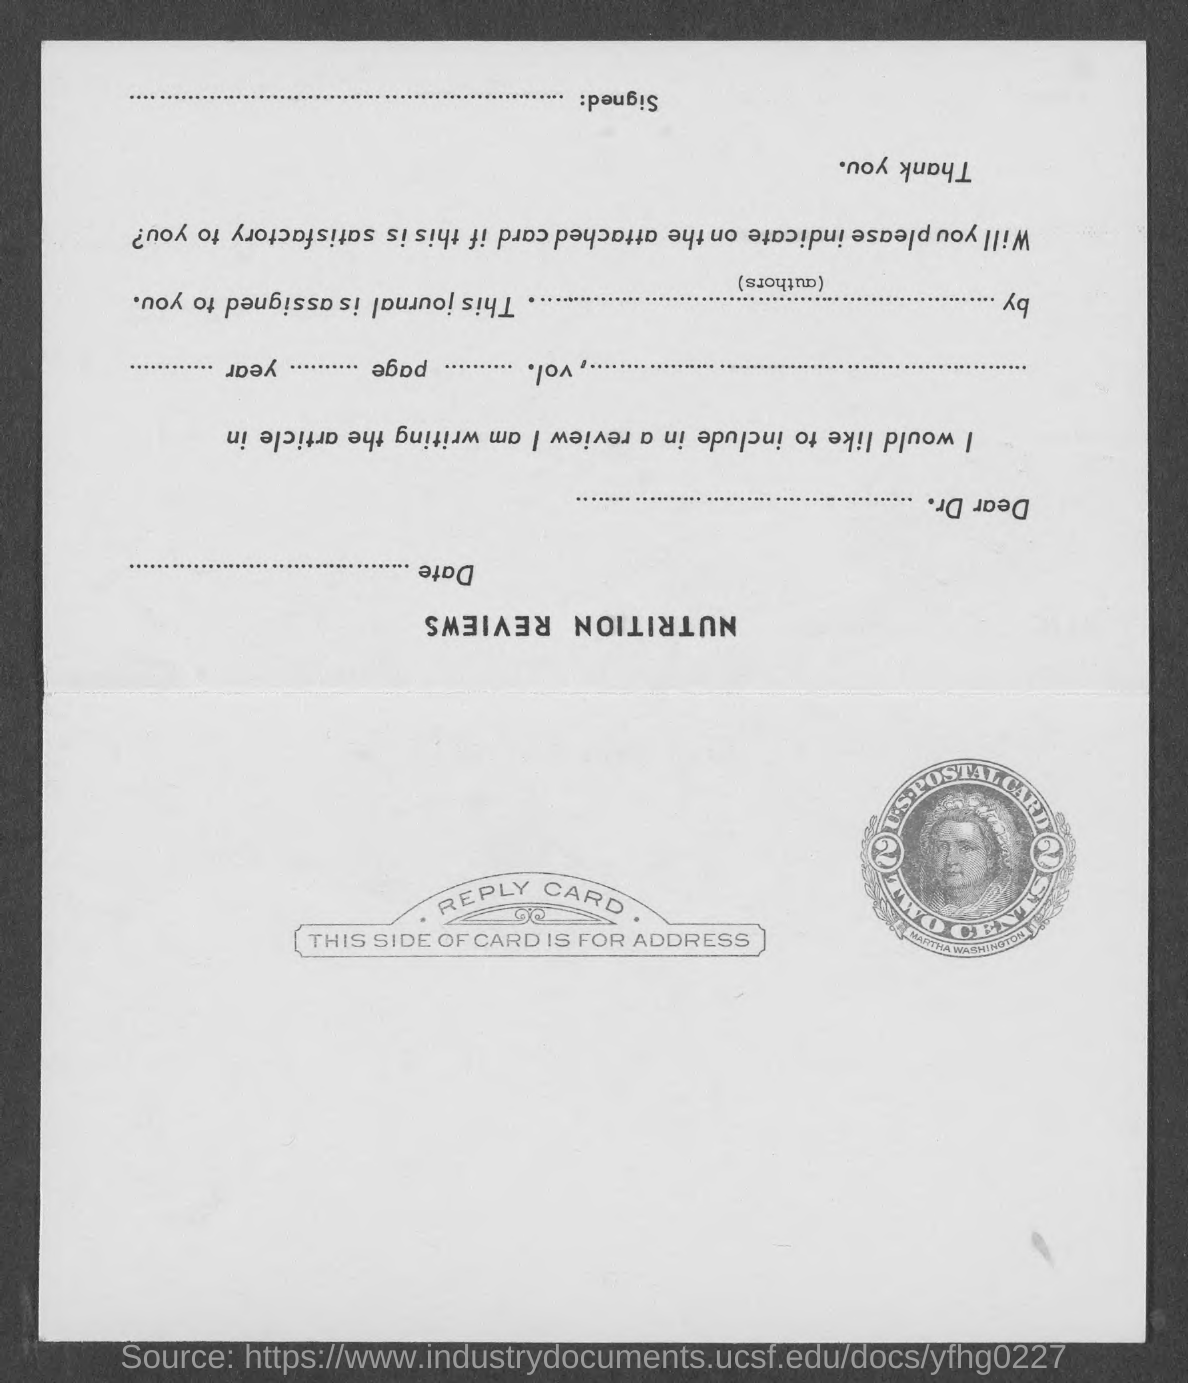What is the cost of the stamp on postal card?
Offer a very short reply. TWO CENTS. What is the name of the person in the stamp?
Offer a terse response. Martha Washington. 